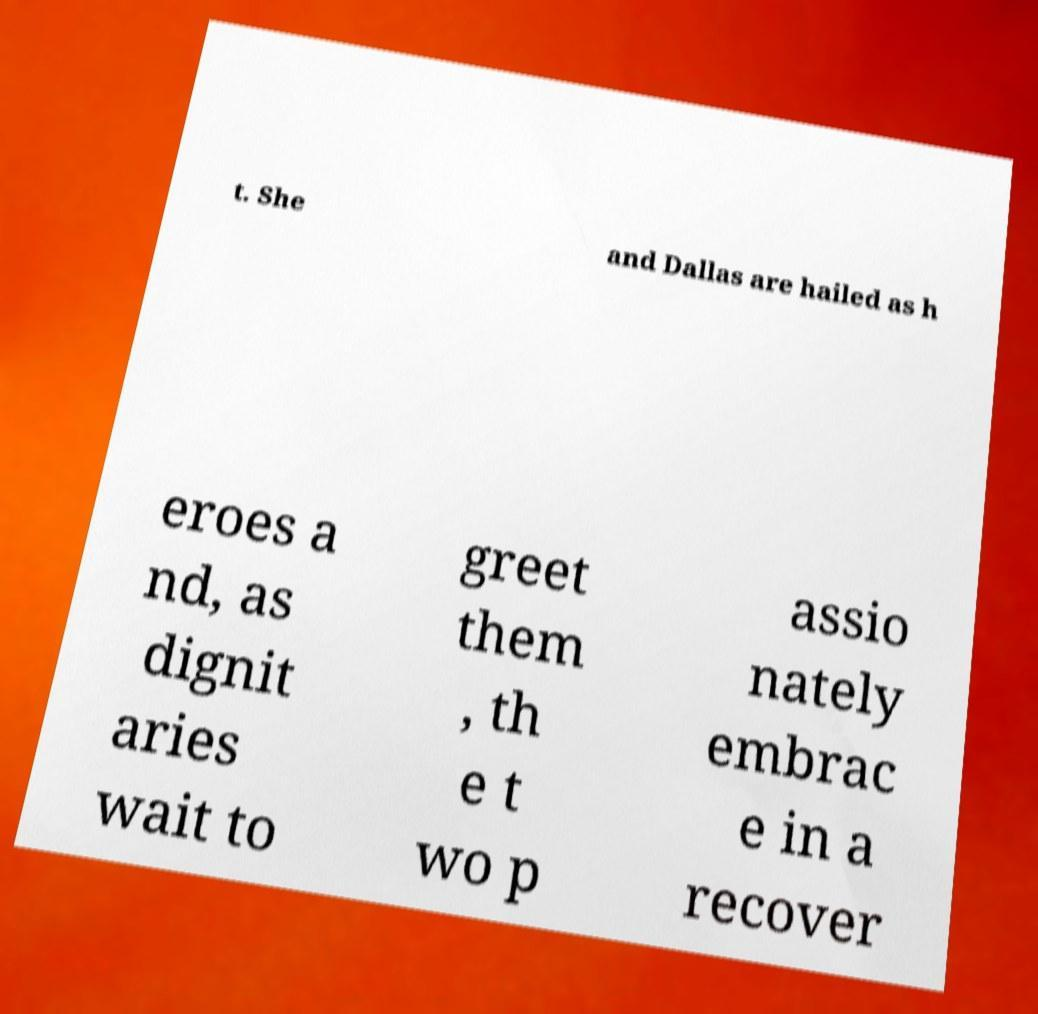What messages or text are displayed in this image? I need them in a readable, typed format. t. She and Dallas are hailed as h eroes a nd, as dignit aries wait to greet them , th e t wo p assio nately embrac e in a recover 